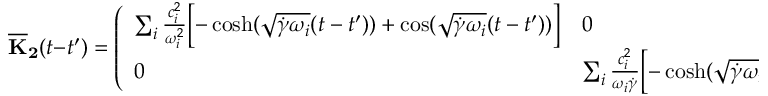Convert formula to latex. <formula><loc_0><loc_0><loc_500><loc_500>{ \overline { K } _ { 2 } } ( t - t ^ { \prime } ) = \left ( \begin{array} { l l } { \sum _ { i } \frac { c _ { i } ^ { 2 } } { \omega _ { i } ^ { 2 } } \left [ - \cosh ( \sqrt { \dot { \gamma } \omega _ { i } } ( t - t ^ { \prime } ) ) + \cos ( \sqrt { \dot { \gamma } \omega _ { i } } ( t - t ^ { \prime } ) ) \right ] } & { 0 } \\ { 0 } & { \sum _ { i } \frac { c _ { i } ^ { 2 } } { \omega _ { i } \dot { \gamma } } \left [ - \cosh ( \sqrt { \dot { \gamma } \omega _ { i } } ( t - t ^ { \prime } ) ) + \cos ( \sqrt { \dot { \gamma } \omega _ { i } } ( t - t ^ { \prime } ) ) \right ] } \end{array} \right ) .</formula> 